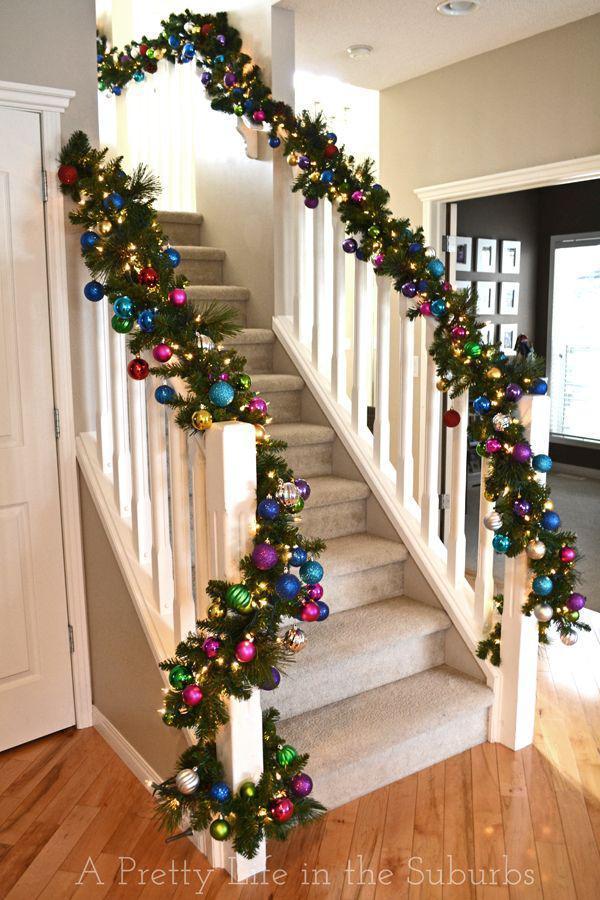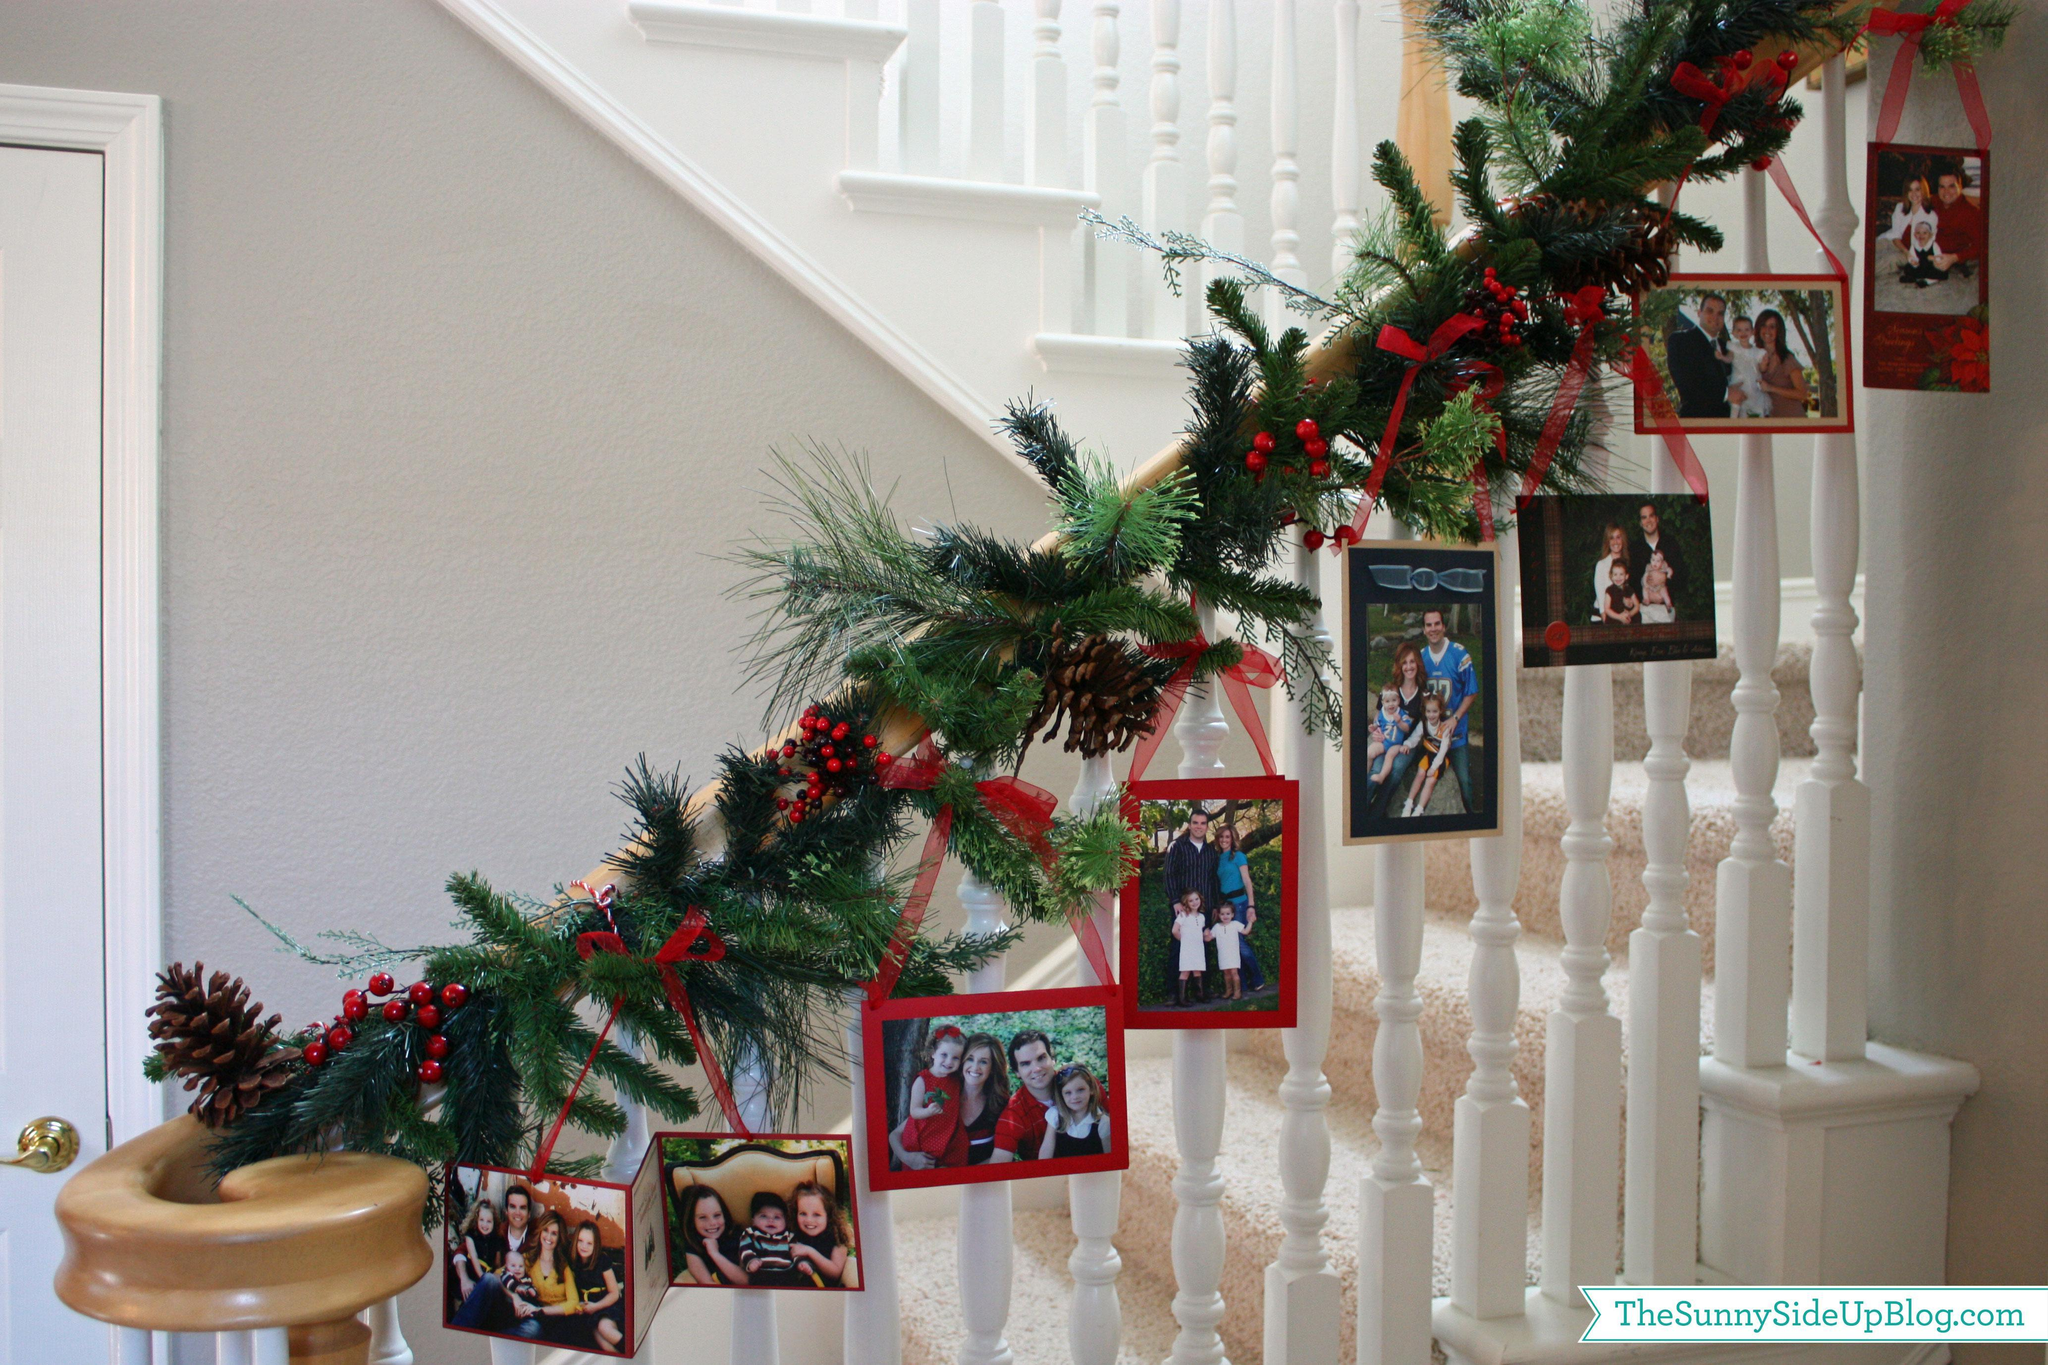The first image is the image on the left, the second image is the image on the right. For the images shown, is this caption "One image shows a staircase with white bars and a brown handrail that descends diagnonally to the right and has an evergreen tree beside it." true? Answer yes or no. No. The first image is the image on the left, the second image is the image on the right. Considering the images on both sides, is "There are no visible windows within any of these rooms." valid? Answer yes or no. No. 